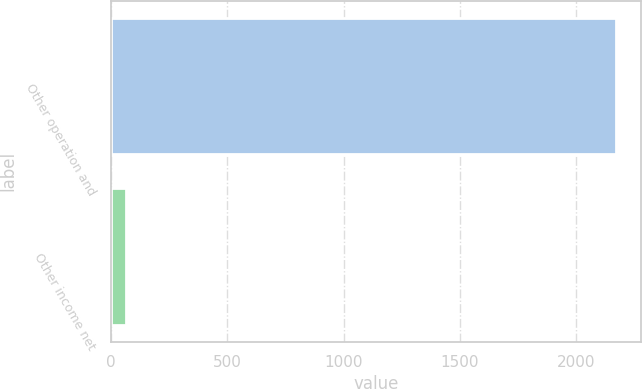<chart> <loc_0><loc_0><loc_500><loc_500><bar_chart><fcel>Other operation and<fcel>Other income net<nl><fcel>2171.3<fcel>66.6<nl></chart> 